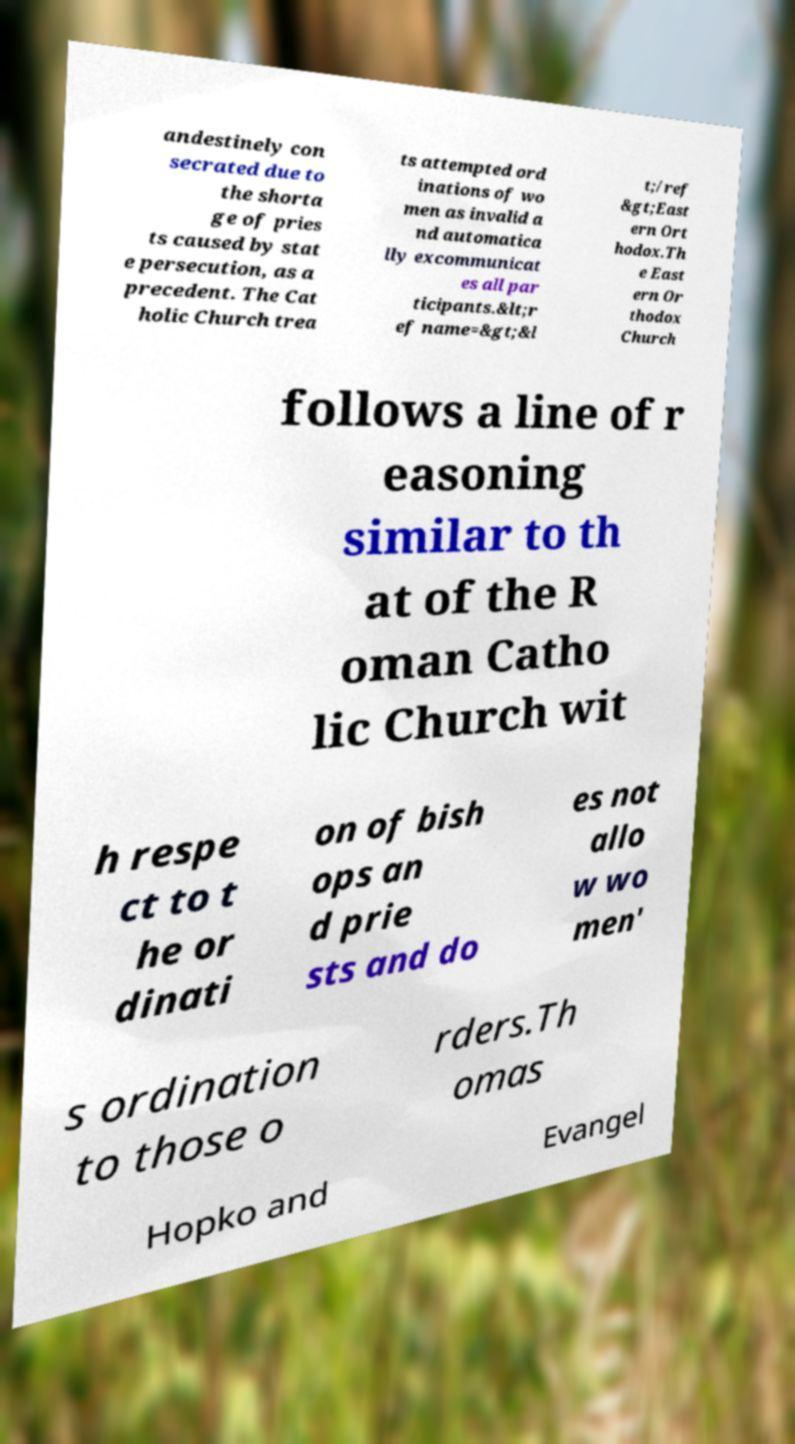What messages or text are displayed in this image? I need them in a readable, typed format. andestinely con secrated due to the shorta ge of pries ts caused by stat e persecution, as a precedent. The Cat holic Church trea ts attempted ord inations of wo men as invalid a nd automatica lly excommunicat es all par ticipants.&lt;r ef name=&gt;&l t;/ref &gt;East ern Ort hodox.Th e East ern Or thodox Church follows a line of r easoning similar to th at of the R oman Catho lic Church wit h respe ct to t he or dinati on of bish ops an d prie sts and do es not allo w wo men' s ordination to those o rders.Th omas Hopko and Evangel 